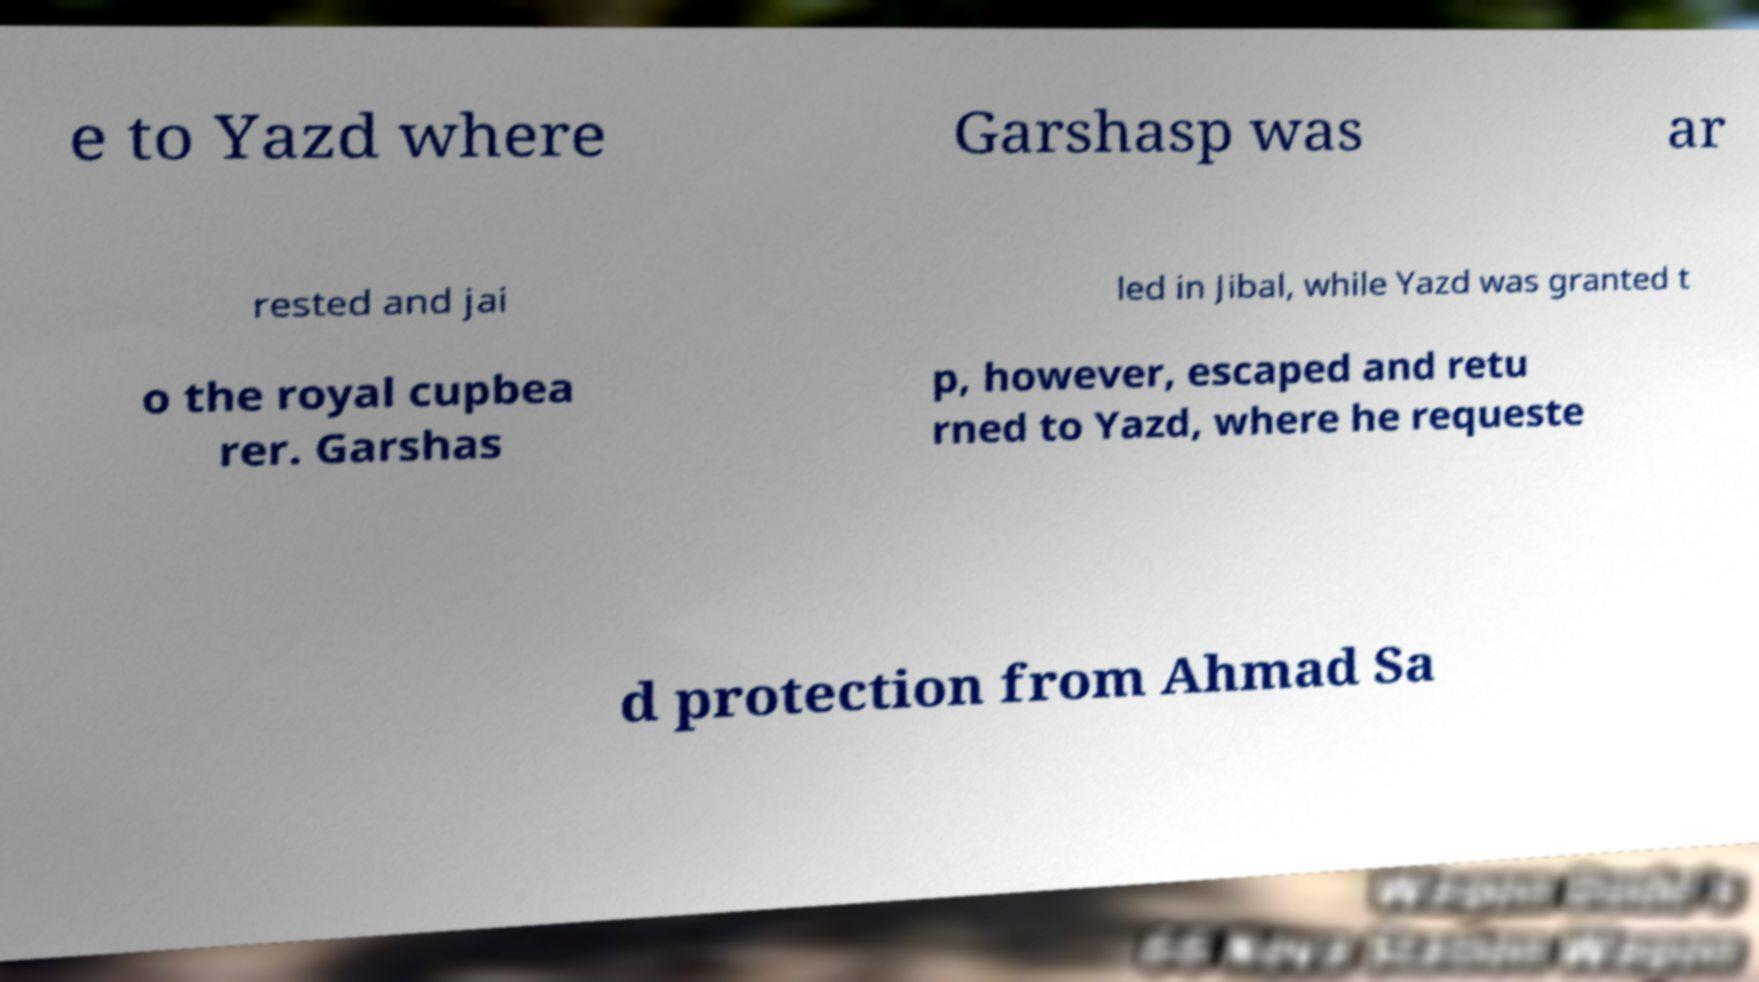There's text embedded in this image that I need extracted. Can you transcribe it verbatim? e to Yazd where Garshasp was ar rested and jai led in Jibal, while Yazd was granted t o the royal cupbea rer. Garshas p, however, escaped and retu rned to Yazd, where he requeste d protection from Ahmad Sa 